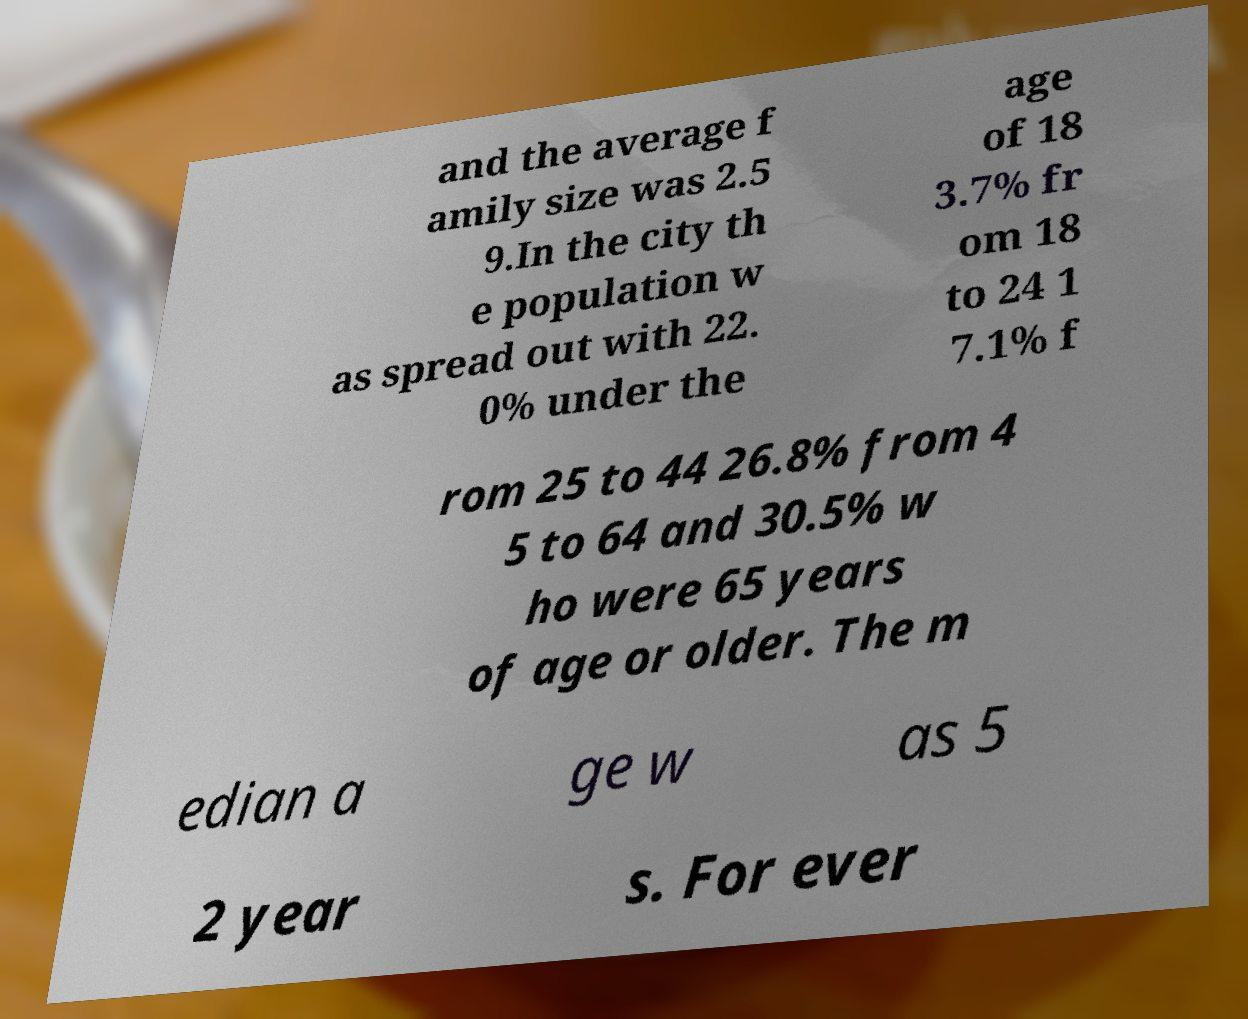I need the written content from this picture converted into text. Can you do that? and the average f amily size was 2.5 9.In the city th e population w as spread out with 22. 0% under the age of 18 3.7% fr om 18 to 24 1 7.1% f rom 25 to 44 26.8% from 4 5 to 64 and 30.5% w ho were 65 years of age or older. The m edian a ge w as 5 2 year s. For ever 